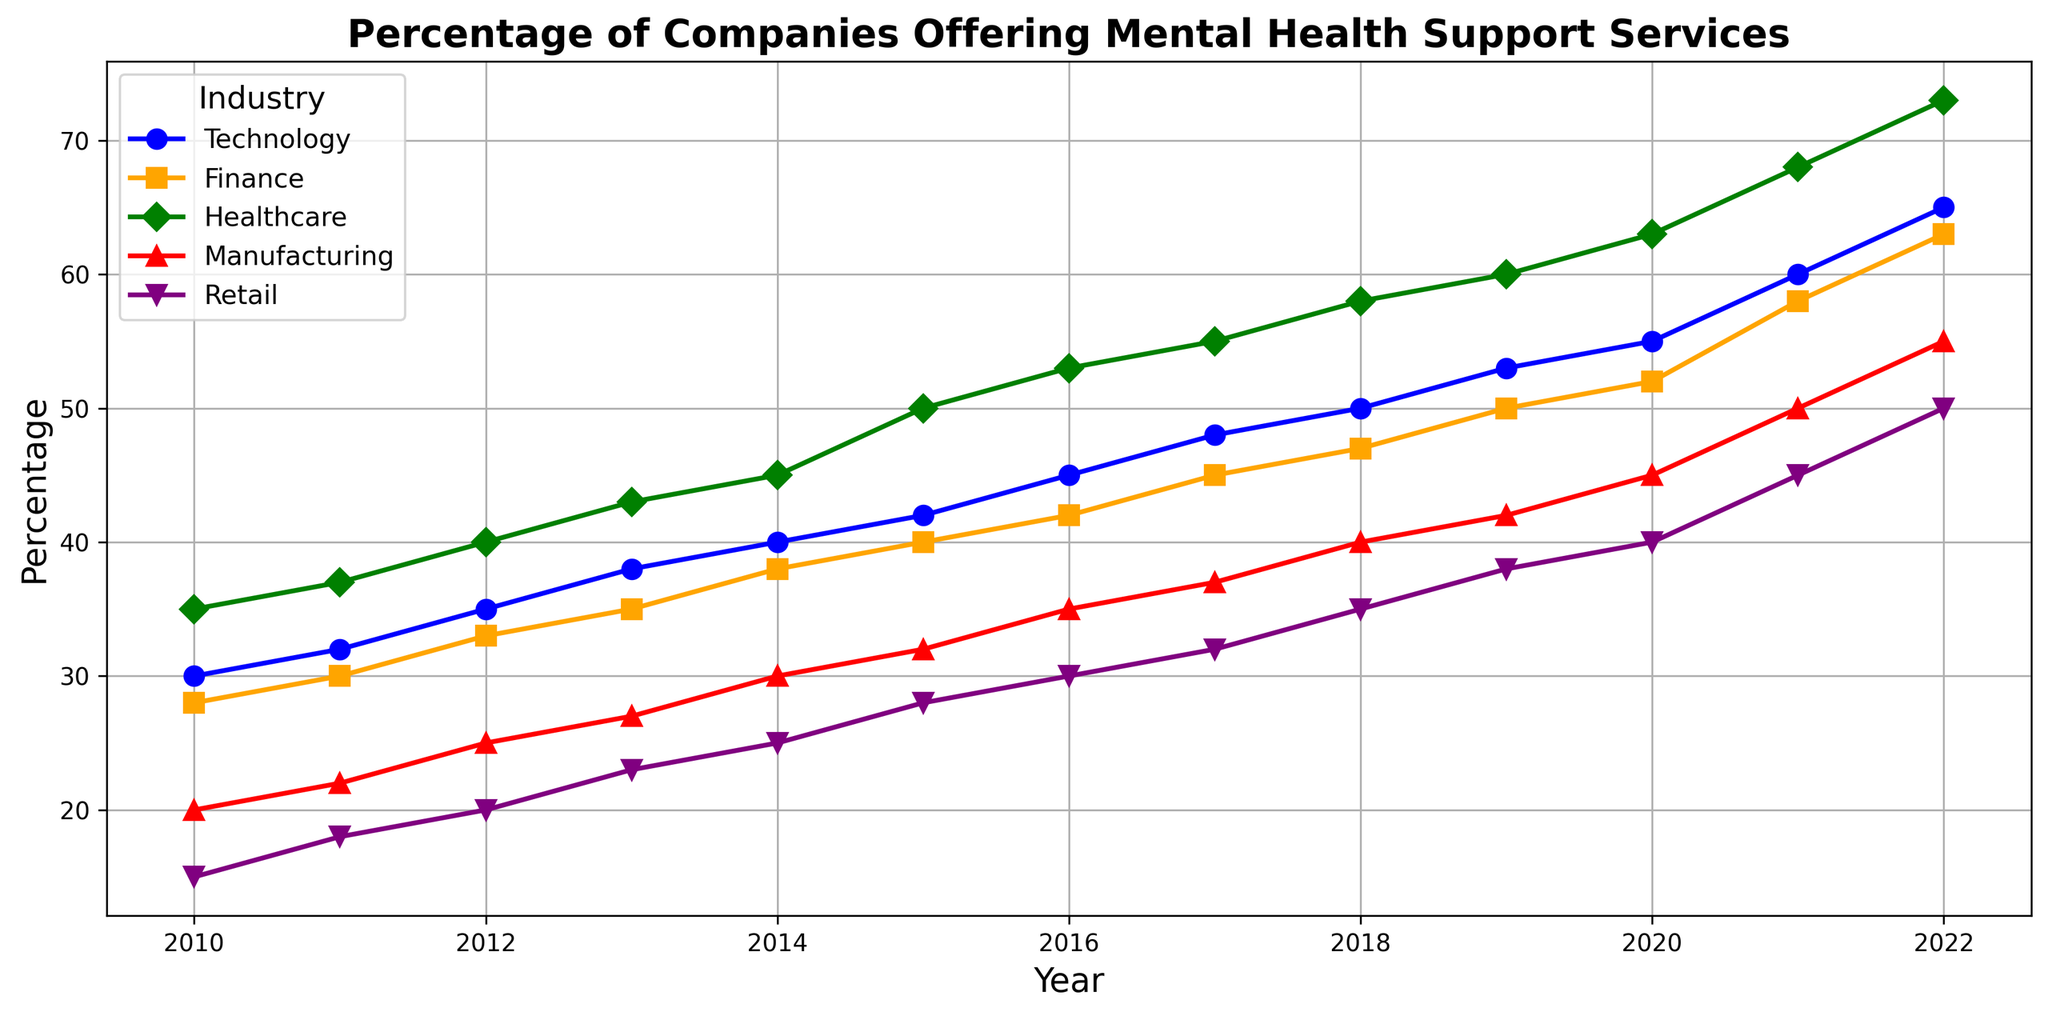What trend can be observed for the Technology industry’s percentage offering mental health support from 2010 to 2022? The graph shows that the percentage of companies in the Technology industry offering mental health support services steadily increases from 30% in 2010 to 65% in 2022.
Answer: Increasing trend Which industry had the highest percentage offering mental health support services in 2015? By examining the lines on the graph for the year 2015, Healthcare had the highest percentage of companies offering mental health support services, at 50%.
Answer: Healthcare What is the difference in the percentage of companies offering mental health support between the Retail and Technology industries in 2020? For 2020, the graph shows Retail at 40% and Technology at 55%. The difference is 55% - 40% = 15%.
Answer: 15% Which industry shows the most rapid increase in the percentage of companies offering mental health support services over the years? Comparing the slopes of the lines, Healthcare shows the steepest increase from 35% in 2010 to 73% in 2022, indicating the most rapid increase.
Answer: Healthcare Which year did the Manufacturing industry first reach a 30% threshold in offering mental health support services? Following the line for Manufacturing, it reached 30% in the year 2014.
Answer: 2014 What was the average percentage of companies offering mental health support services in the Finance industry from 2010 to 2015? From the graph, the percentages for Finance from 2010 to 2015 are 28, 30, 33, 35, 38, and 40. The average is (28 + 30 + 33 + 35 + 38 + 40) / 6 = 34%.
Answer: 34% Compare the percentages of the Manufacturing and Retail industries in 2017. Which is higher? In 2017, the Manufacturing industry is at 37% and the Retail industry is at 32%. Manufacturing is higher.
Answer: Manufacturing What visual pattern do you observe in the Retail industry line from 2010 to 2022? The line for the Retail industry starts at a low percentage, shows a slow and steady increase, and ends at 50% in 2022.
Answer: Slow and steady increase What is the cumulative increase in the percentage of companies offering mental health support in the Healthcare industry from 2010 to 2015? In 2010, Healthcare is at 35%, and in 2015, it is at 50%. The cumulative increase is 50% - 35% = 15%.
Answer: 15% 